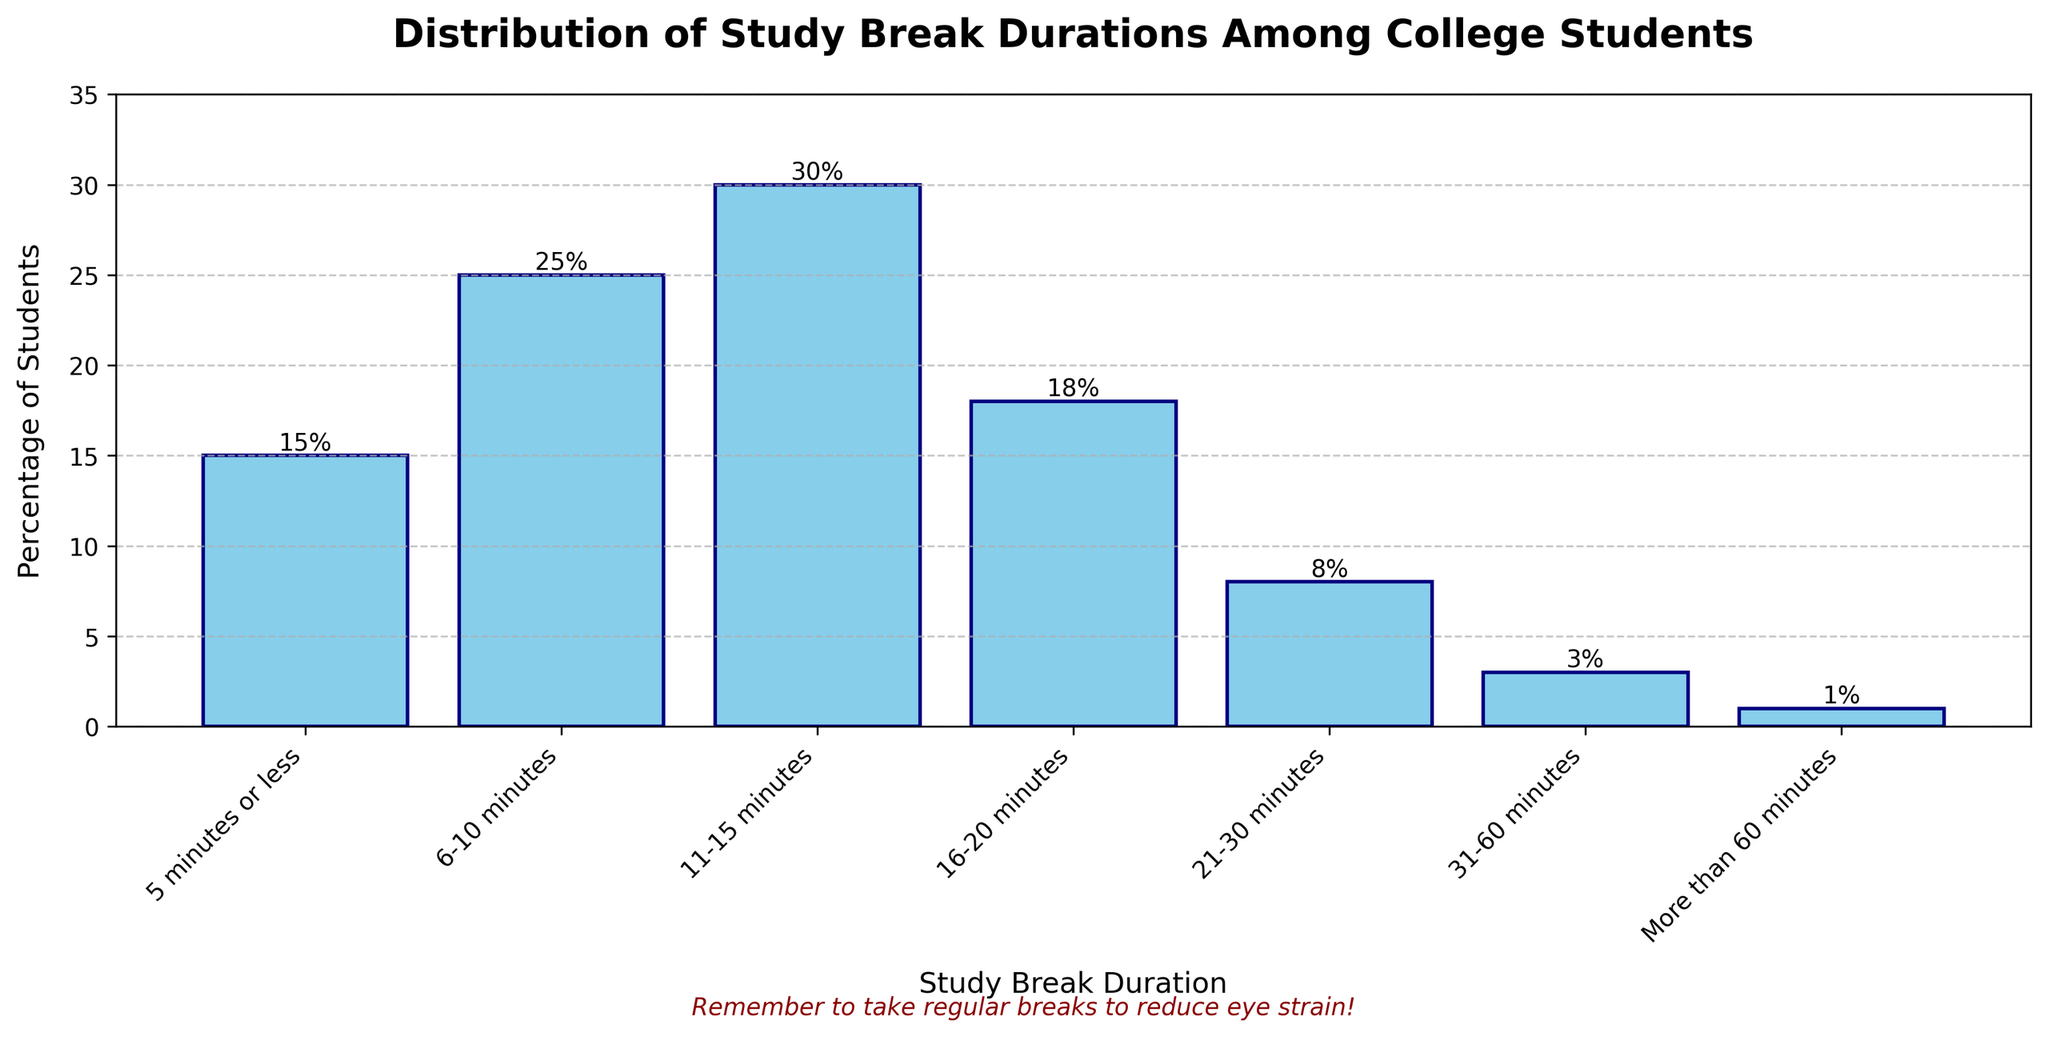What's the most common study break duration among college students? The bar for 11-15 minutes is the highest, indicating that the most common study break duration among college students is 11-15 minutes.
Answer: 11-15 minutes How many more students take breaks of 6-10 minutes compared to breaks of 16-20 minutes? The percentage of students taking 6-10 minute breaks is 25%, and those taking 16-20 minute breaks is 18%. The difference is 25% - 18% = 7%.
Answer: 7% What is the total percentage of students who take breaks of 15 minutes or less? Add the percentages of students taking breaks of 5 minutes or less, 6-10 minutes, and 11-15 minutes: 15% + 25% + 30% = 70%.
Answer: 70% What percentage of students take breaks of more than 30 minutes? The percentage of students taking breaks of 31-60 minutes is 3%, and those taking breaks of more than 60 minutes is 1%. Adding these gives 3% + 1% = 4%.
Answer: 4% Are there more students who take breaks between 21 and 30 minutes than those who take breaks of 6-10 minutes? The percentage of students taking breaks of 21-30 minutes is 8%, while for 6-10 minutes, it's 25%. Since 25% is greater than 8%, more students take 6-10 minute breaks.
Answer: No What is the median value of the percentage of students taking various break durations? The percentages in ascending order are [1, 3, 8, 15, 18, 25, 30]. The median value, being the fourth value in this ordered list, is 18%.
Answer: 18% Which break duration has the second highest percentage of students? The bar for 11-15 minutes has the highest percentage at 30%. The second highest is 6-10 minutes at 25%.
Answer: 6-10 minutes What's the combined percentage of students who take breaks of 20 minutes or less? Add the percentages of students taking breaks of 5 minutes or less, 6-10 minutes, 11-15 minutes, and 16-20 minutes: 15% + 25% + 30% + 18% = 88%.
Answer: 88% Do fewer students take breaks of 16-20 minutes compared to those who take breaks of 5 minutes or less? The percentage of students taking breaks of 16-20 minutes is 18%, and those taking breaks of 5 minutes or less is 15%. Since 18% is greater than 15%, more students take 16-20 minute breaks.
Answer: No Which break duration has the fewest students? The bar for "More than 60 minutes" is the shortest, indicating the fewest percentage of students at 1%.
Answer: More than 60 minutes 